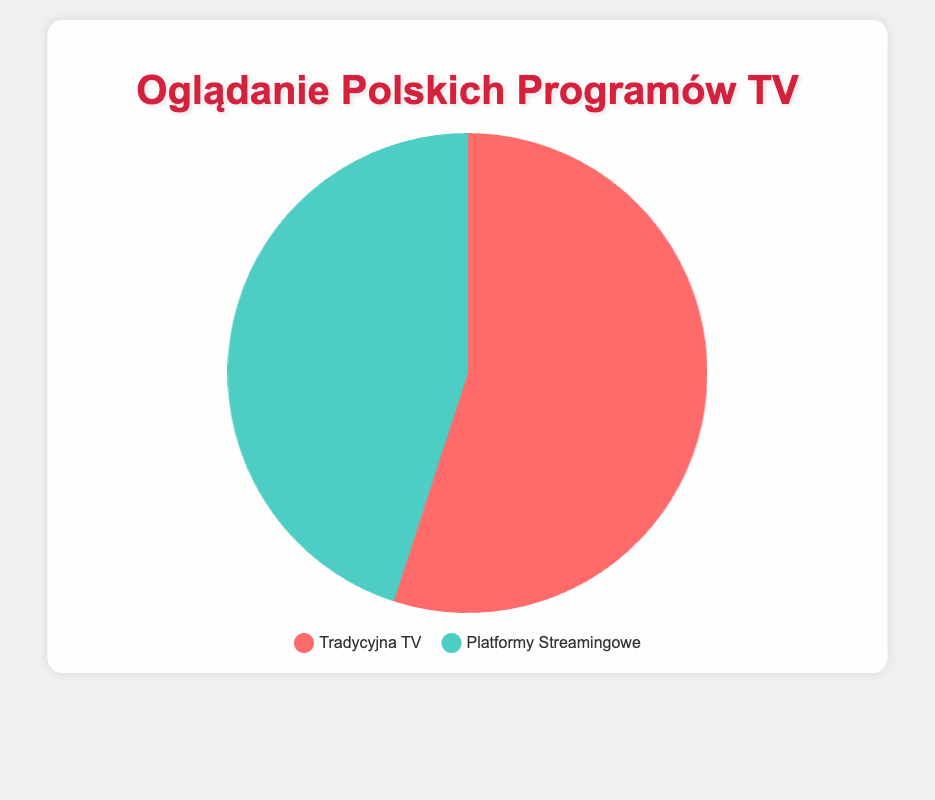Which viewing method has a higher percentage of viewers? The percentage of viewers using Traditional TV is 55%, which is higher than the 45% of viewers using Streaming Platforms.
Answer: Traditional TV What's the percentage difference between viewers using Traditional TV and viewers using Streaming Platforms? The percentage of viewers using Traditional TV is 55%, while it is 45% for Streaming Platforms. The difference is 55% - 45% = 10%.
Answer: 10% If the total number of viewers surveyed is 1000, how many are watching Polish shows on streaming platforms? If 45% of the viewers are using Streaming Platforms, then the number of viewers is (45/100) * 1000 = 450.
Answer: 450 How do the percentages of viewers on Traditional TV and Streaming Platforms compare to each other? Traditional TV has 55% of viewers, which is greater than the 45% of viewers on Streaming Platforms.
Answer: Traditional TV > Streaming Platforms What color represents viewers using Traditional TV? The legend shows that the color representing Traditional TV is red.
Answer: Red What color represents viewers using Streaming Platforms? The legend shows that the color representing Streaming Platforms is green.
Answer: Green What is the total percentage represented by both Traditional TV and Streaming Platforms? The total percentage is the sum of the percentage of viewers using Traditional TV and Streaming Platforms, which is 55% + 45% = 100%.
Answer: 100% If 25 more viewers switch from Traditional TV to Streaming Platforms, how will the percentages change? Initially, there are 550 viewers on Traditional TV (55%) and 450 viewers on Streaming Platforms (45%) out of 1000 viewers. Moving 25 viewers changes the counts to 525 for Traditional TV and 475 for Streaming Platforms. The new percentages are (525/1000)*100 = 52.5% for Traditional TV and (475/1000)*100 = 47.5% for Streaming Platforms.
Answer: Traditional TV: 52.5%, Streaming Platforms: 47.5% 